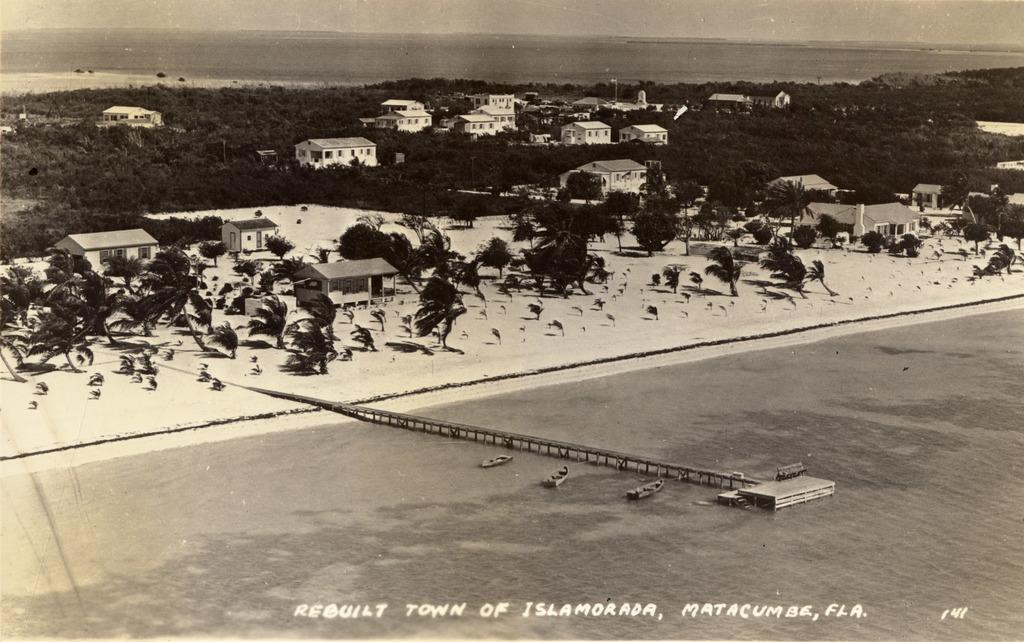What state is mentioned?
Give a very brief answer. Florida. 